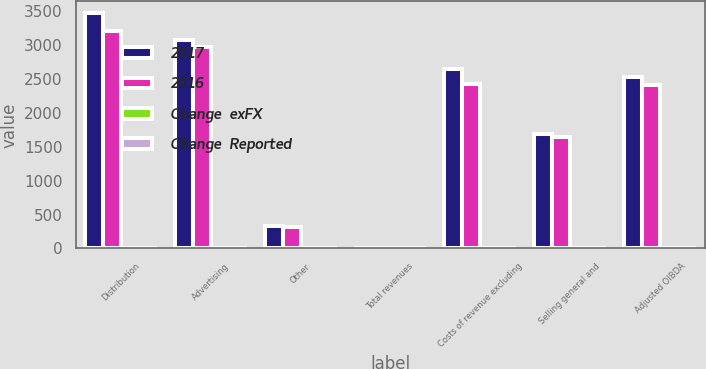Convert chart to OTSL. <chart><loc_0><loc_0><loc_500><loc_500><stacked_bar_chart><ecel><fcel>Distribution<fcel>Advertising<fcel>Other<fcel>Total revenues<fcel>Costs of revenue excluding<fcel>Selling general and<fcel>Adjusted OIBDA<nl><fcel>2017<fcel>3474<fcel>3073<fcel>326<fcel>8.5<fcel>2656<fcel>1686<fcel>2531<nl><fcel>2016<fcel>3213<fcel>2970<fcel>314<fcel>8.5<fcel>2432<fcel>1652<fcel>2413<nl><fcel>Change  exFX<fcel>8<fcel>3<fcel>4<fcel>6<fcel>9<fcel>2<fcel>5<nl><fcel>Change  Reported<fcel>7<fcel>3<fcel>6<fcel>5<fcel>8<fcel>2<fcel>5<nl></chart> 